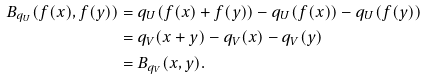Convert formula to latex. <formula><loc_0><loc_0><loc_500><loc_500>B _ { q _ { U } } ( f ( x ) , f ( y ) ) & = q _ { U } ( f ( x ) + f ( y ) ) - q _ { U } ( f ( x ) ) - q _ { U } ( f ( y ) ) \\ & = q _ { V } ( x + y ) - q _ { V } ( x ) - q _ { V } ( y ) \\ & = B _ { q _ { V } } ( x , y ) .</formula> 